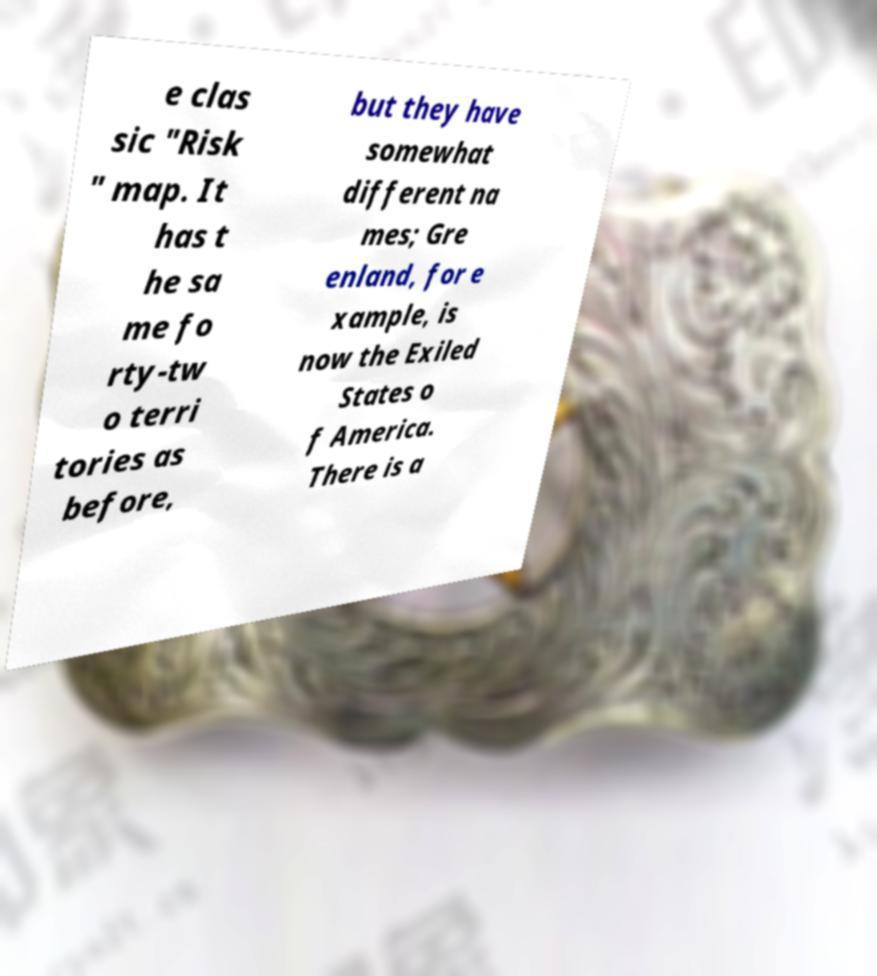Could you assist in decoding the text presented in this image and type it out clearly? e clas sic "Risk " map. It has t he sa me fo rty-tw o terri tories as before, but they have somewhat different na mes; Gre enland, for e xample, is now the Exiled States o f America. There is a 